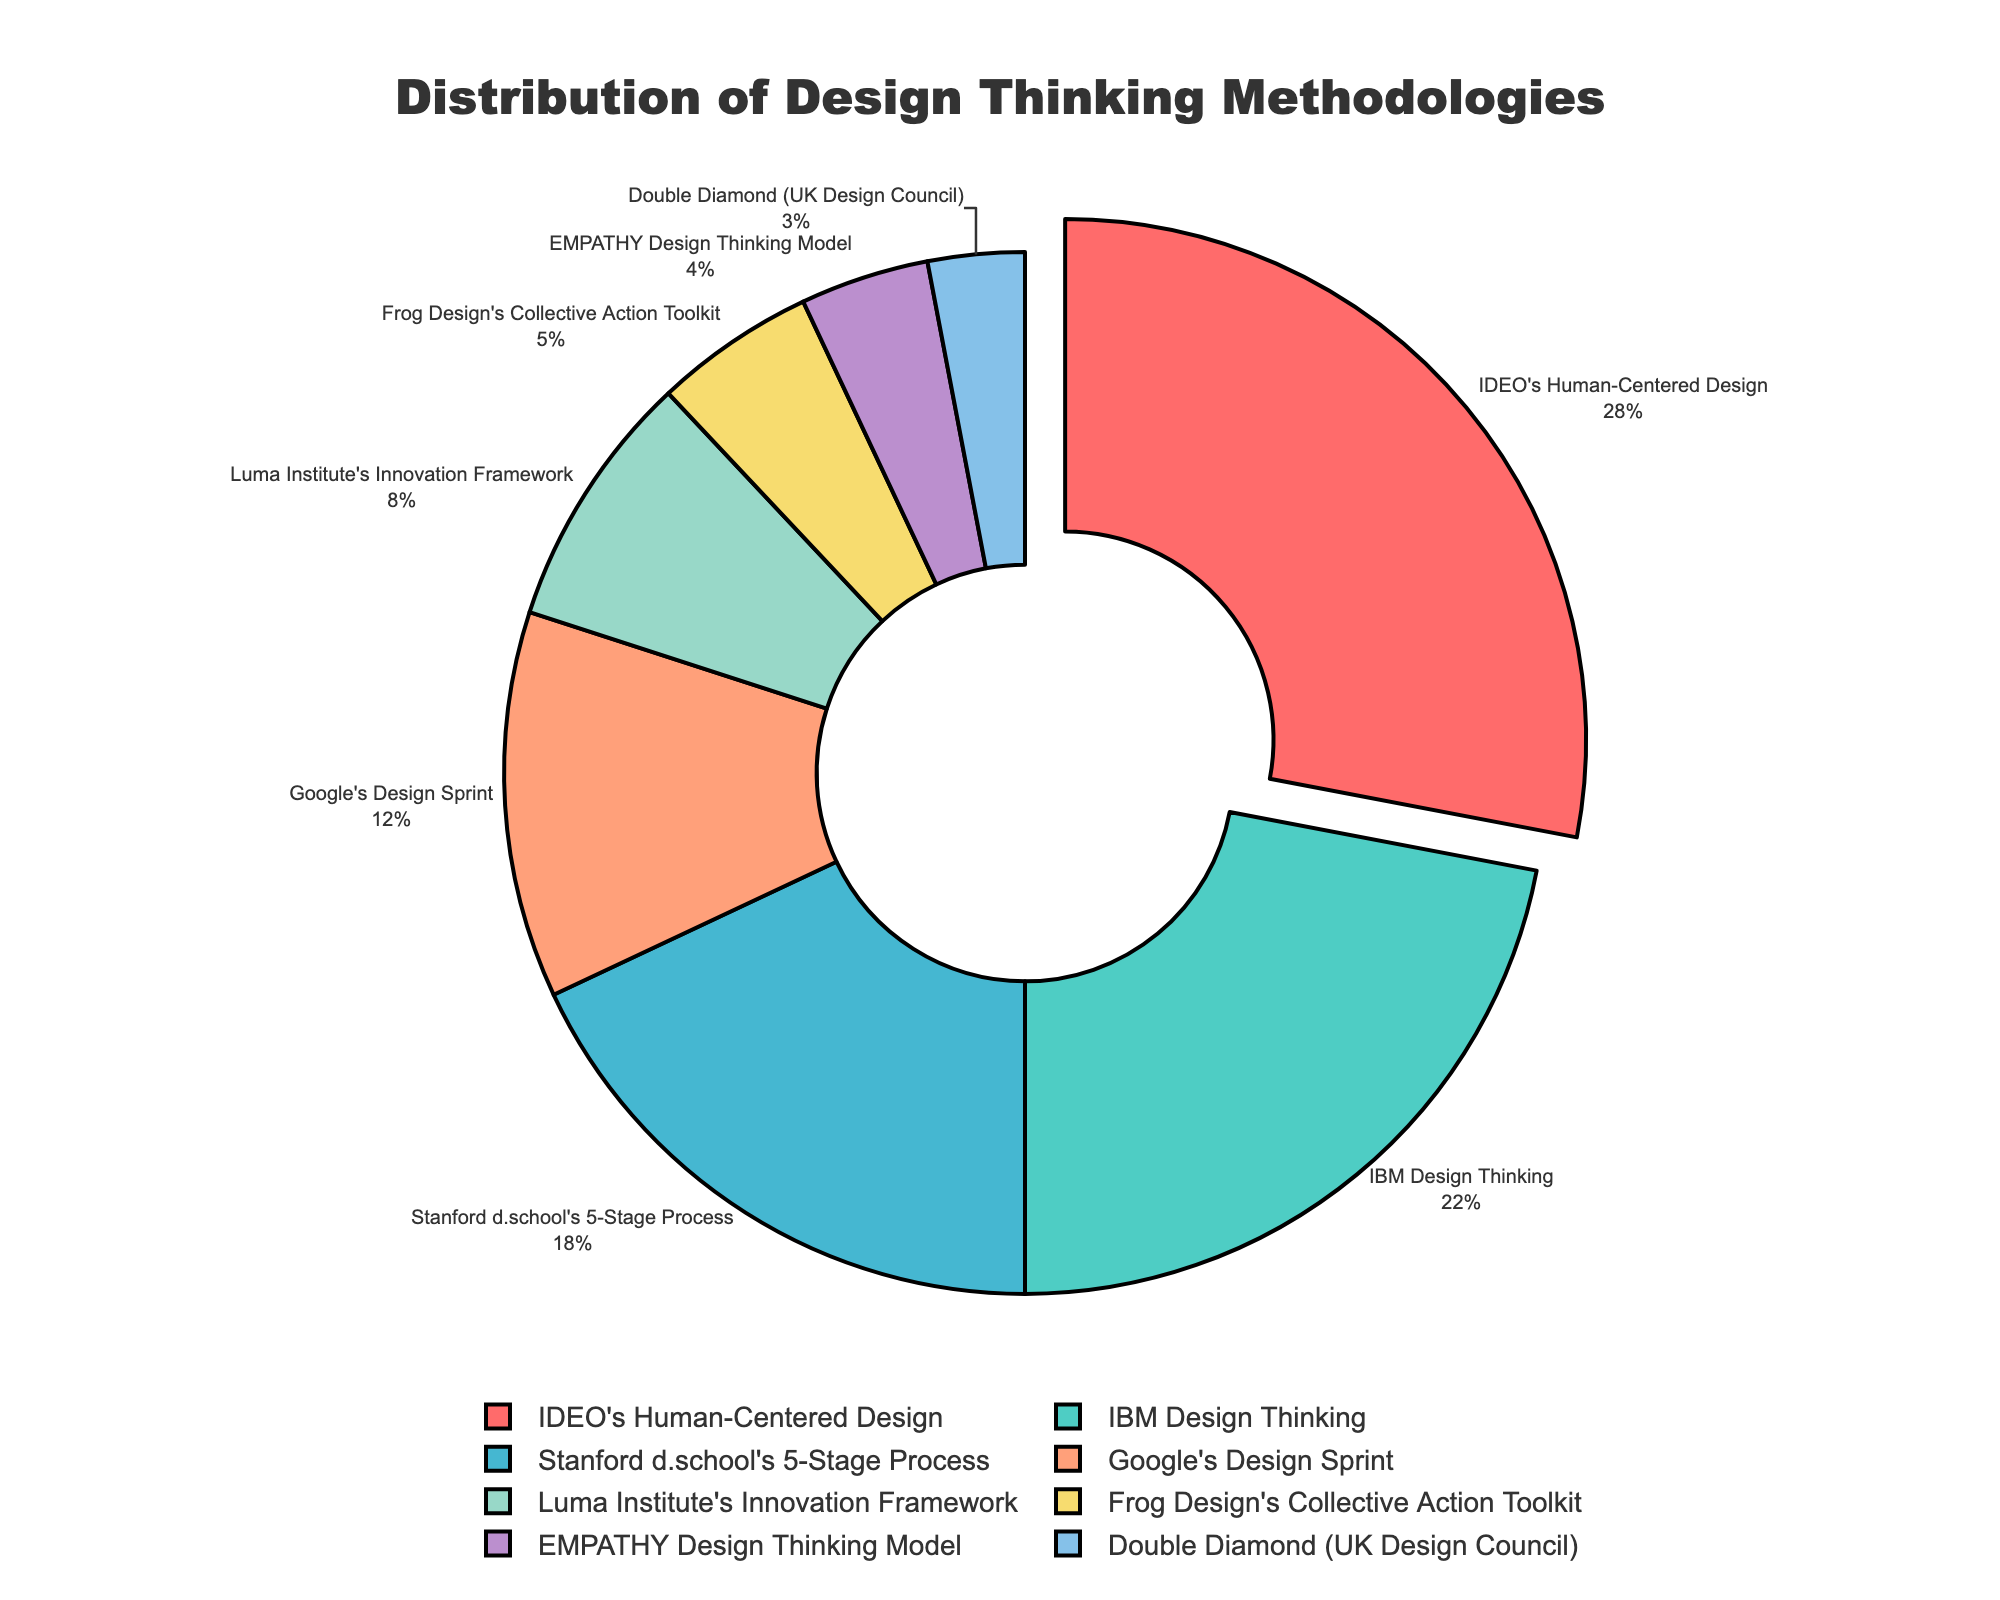Which methodology has the highest percentage in the pie chart? Identify the largest segment in the pie chart and read the corresponding label. The largest segment represents 28%, which corresponds to IDEO's Human-Centered Design.
Answer: IDEO's Human-Centered Design Compare the combined percentage of Stanford d.school's 5-Stage Process and Google's Design Sprint to IBM Design Thinking. Which is higher? Sum the percentages of Stanford d.school's 5-Stage Process (18%) and Google's Design Sprint (12%), then compare the result to IBM Design Thinking (22%). The sum is 18% + 12% = 30%, which is higher than 22%.
Answer: Stanford d.school's 5-Stage Process and Google's Design Sprint combined What is the difference in percentage between the methodology used the least and the methodology used the most? Identify the least used methodology (Double Diamond at 3%) and the most used methodology (IDEO's Human-Centered Design at 28%). Subtract the percentage of the least used from the most used: 28% - 3% = 25%.
Answer: 25% Which methodologies combined make up more than 50% of the chart? Sum the percentages from the largest and next largest segments until the sum exceeds 50%. Adding IDEO's HCD (28%) and IBM Design Thinking (22%) gives 28% + 22% = 50%, which is exactly 50%. Adding Stanford d.school's (18%) exceeds 50%.
Answer: IDEO's Human-Centered Design, IBM Design Thinking, and Stanford d.school's 5-Stage Process How many methodologies have a percentage lower than 10%? Count the segments with percentages below 10%. The segments are Luma Institute's (8%), Frog Design's (5%), EMPATHY Design Thinking Model (4%), and Double Diamond (3%). There are 4 segments in total.
Answer: 4 Which methodology is represented by the segment that is pulled out from the pie chart? Observe which segment is visually separated from the rest of the pie chart (pulled out). The segment pulled out is labeled as IDEO's Human-Centered Design.
Answer: IDEO's Human-Centered Design Is the combined percentage of Luma Institute's Innovation Framework and Frog Design's Collective Action Toolkit greater than or less than that of Google's Design Sprint? Sum the percentages of Luma Institute's (8%) and Frog Design's (5%) and compare to Google's Design Sprint (12%). The sum is 8% + 5% = 13%, which is greater than 12%.
Answer: Greater than What is the average percentage of all methodologies listed? Calculate the sum of all percentages and divide by the number of methodologies. The sum is 28% + 22% + 18% + 12% + 8% + 5% + 4% + 3% = 100%. Divide by 8 (number of methodologies). The average is 100% / 8 = 12.5%.
Answer: 12.5% 